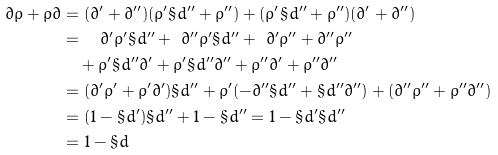<formula> <loc_0><loc_0><loc_500><loc_500>\partial \rho + \rho \partial & = ( \partial ^ { \prime } + \partial ^ { \prime \prime } ) ( \rho ^ { \prime } \S d ^ { \prime \prime } + \rho ^ { \prime \prime } ) + ( \rho ^ { \prime } \S d ^ { \prime \prime } + \rho ^ { \prime \prime } ) ( \partial ^ { \prime } + \partial ^ { \prime \prime } ) \\ & = \quad \partial ^ { \prime } \rho ^ { \prime } \S d ^ { \prime \prime } + \ \partial ^ { \prime \prime } \rho ^ { \prime } \S d ^ { \prime \prime } + \ \partial ^ { \prime } \rho ^ { \prime \prime } + \partial ^ { \prime \prime } \rho ^ { \prime \prime } \\ & \quad + \rho ^ { \prime } \S d ^ { \prime \prime } \partial ^ { \prime } + \rho ^ { \prime } \S d ^ { \prime \prime } \partial ^ { \prime \prime } + \rho ^ { \prime \prime } \partial ^ { \prime } + \rho ^ { \prime \prime } \partial ^ { \prime \prime } \\ & = ( \partial ^ { \prime } \rho ^ { \prime } + \rho ^ { \prime } \partial ^ { \prime } ) \S d ^ { \prime \prime } + \rho ^ { \prime } ( - \partial ^ { \prime \prime } \S d ^ { \prime \prime } + \S d ^ { \prime \prime } \partial ^ { \prime \prime } ) + ( \partial ^ { \prime \prime } \rho ^ { \prime \prime } + \rho ^ { \prime \prime } \partial ^ { \prime \prime } ) \\ & = ( 1 - \S d ^ { \prime } ) \S d ^ { \prime \prime } + 1 - \S d ^ { \prime \prime } = 1 - \S d ^ { \prime } \S d ^ { \prime \prime } \\ & = 1 - \S d</formula> 